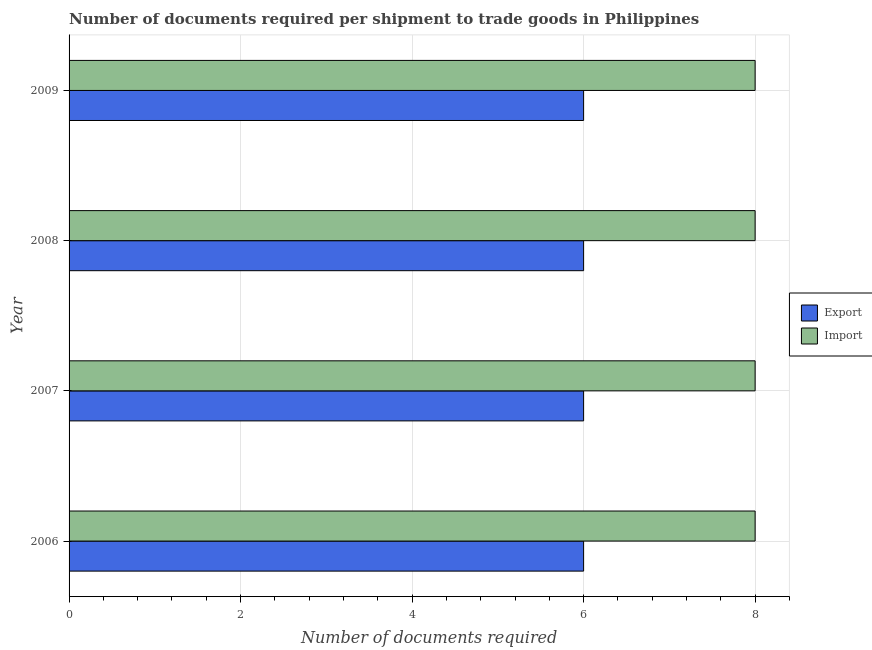How many different coloured bars are there?
Make the answer very short. 2. Are the number of bars per tick equal to the number of legend labels?
Your answer should be very brief. Yes. What is the label of the 1st group of bars from the top?
Keep it short and to the point. 2009. What is the number of documents required to import goods in 2006?
Ensure brevity in your answer.  8. Across all years, what is the minimum number of documents required to import goods?
Your response must be concise. 8. In which year was the number of documents required to export goods maximum?
Offer a very short reply. 2006. What is the total number of documents required to export goods in the graph?
Make the answer very short. 24. What is the difference between the number of documents required to export goods in 2008 and that in 2009?
Give a very brief answer. 0. What is the difference between the number of documents required to export goods in 2006 and the number of documents required to import goods in 2007?
Ensure brevity in your answer.  -2. In the year 2009, what is the difference between the number of documents required to export goods and number of documents required to import goods?
Your answer should be compact. -2. Is the number of documents required to import goods in 2007 less than that in 2008?
Your answer should be compact. No. Is the difference between the number of documents required to export goods in 2007 and 2009 greater than the difference between the number of documents required to import goods in 2007 and 2009?
Provide a short and direct response. No. What is the difference between the highest and the second highest number of documents required to import goods?
Give a very brief answer. 0. What does the 2nd bar from the top in 2007 represents?
Provide a short and direct response. Export. What does the 2nd bar from the bottom in 2007 represents?
Make the answer very short. Import. How many bars are there?
Provide a short and direct response. 8. Are all the bars in the graph horizontal?
Give a very brief answer. Yes. How many years are there in the graph?
Keep it short and to the point. 4. What is the difference between two consecutive major ticks on the X-axis?
Offer a very short reply. 2. Are the values on the major ticks of X-axis written in scientific E-notation?
Ensure brevity in your answer.  No. Does the graph contain any zero values?
Your answer should be compact. No. Does the graph contain grids?
Give a very brief answer. Yes. Where does the legend appear in the graph?
Your response must be concise. Center right. How are the legend labels stacked?
Offer a terse response. Vertical. What is the title of the graph?
Your answer should be compact. Number of documents required per shipment to trade goods in Philippines. What is the label or title of the X-axis?
Your answer should be very brief. Number of documents required. What is the label or title of the Y-axis?
Offer a terse response. Year. What is the Number of documents required of Export in 2006?
Provide a short and direct response. 6. What is the Number of documents required of Export in 2007?
Ensure brevity in your answer.  6. What is the Number of documents required of Import in 2009?
Give a very brief answer. 8. Across all years, what is the maximum Number of documents required of Export?
Provide a succinct answer. 6. What is the total Number of documents required of Import in the graph?
Offer a very short reply. 32. What is the difference between the Number of documents required of Export in 2006 and that in 2007?
Give a very brief answer. 0. What is the difference between the Number of documents required in Export in 2006 and that in 2008?
Offer a very short reply. 0. What is the difference between the Number of documents required of Import in 2006 and that in 2009?
Your answer should be very brief. 0. What is the difference between the Number of documents required in Export in 2007 and that in 2009?
Keep it short and to the point. 0. What is the difference between the Number of documents required in Import in 2007 and that in 2009?
Your response must be concise. 0. What is the difference between the Number of documents required of Export in 2008 and that in 2009?
Offer a very short reply. 0. What is the difference between the Number of documents required of Import in 2008 and that in 2009?
Your answer should be compact. 0. What is the difference between the Number of documents required in Export in 2006 and the Number of documents required in Import in 2009?
Keep it short and to the point. -2. What is the difference between the Number of documents required in Export in 2007 and the Number of documents required in Import in 2008?
Provide a short and direct response. -2. What is the difference between the Number of documents required in Export in 2007 and the Number of documents required in Import in 2009?
Offer a very short reply. -2. What is the average Number of documents required in Export per year?
Your answer should be compact. 6. In the year 2006, what is the difference between the Number of documents required in Export and Number of documents required in Import?
Provide a short and direct response. -2. In the year 2009, what is the difference between the Number of documents required in Export and Number of documents required in Import?
Your answer should be very brief. -2. What is the ratio of the Number of documents required of Export in 2006 to that in 2007?
Provide a short and direct response. 1. What is the ratio of the Number of documents required of Export in 2006 to that in 2009?
Your response must be concise. 1. What is the ratio of the Number of documents required of Export in 2007 to that in 2009?
Ensure brevity in your answer.  1. What is the ratio of the Number of documents required of Import in 2008 to that in 2009?
Offer a very short reply. 1. What is the difference between the highest and the lowest Number of documents required in Export?
Your answer should be compact. 0. 